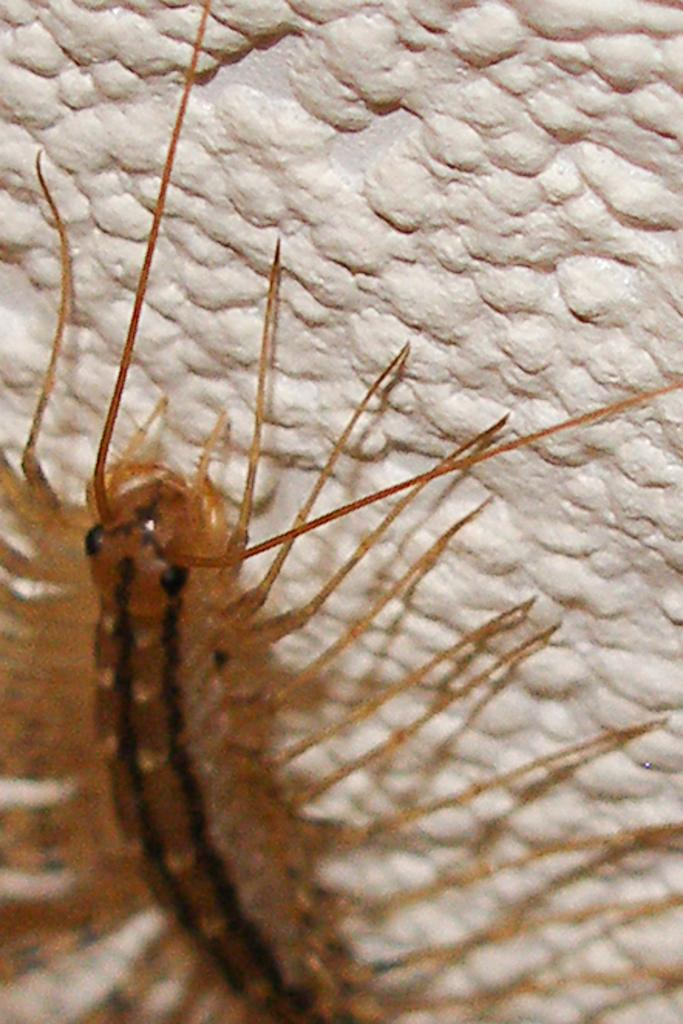What type of creature can be seen on the wall in the image? There is an insect present on the wall in the image. What type of sweater is the duck wearing in the image? There is no duck or sweater present in the image; it features an insect on the wall. Can you tell me how many monkeys are climbing on the wall in the image? There are no monkeys present in the image; it features an insect on the wall. 